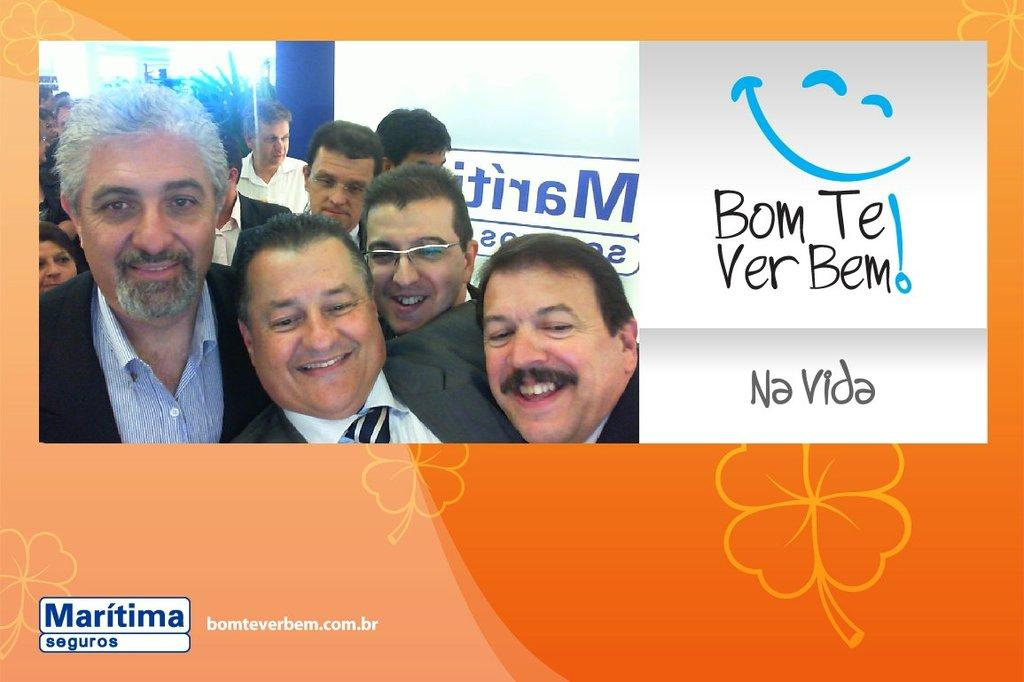What is featured in the picture? There is a poster in the picture. What is depicted on the poster? The poster contains an image of men. What are the men in the image doing? The men are standing. What are the men wearing in the image? The men are wearing blazers. What else can be seen on the poster besides the image of the men? There is text on the poster. Can you see a carriage in the image? There is no carriage present in the image. Is there a crown visible on any of the men in the image? There is no crown visible on any of the men in the image. 